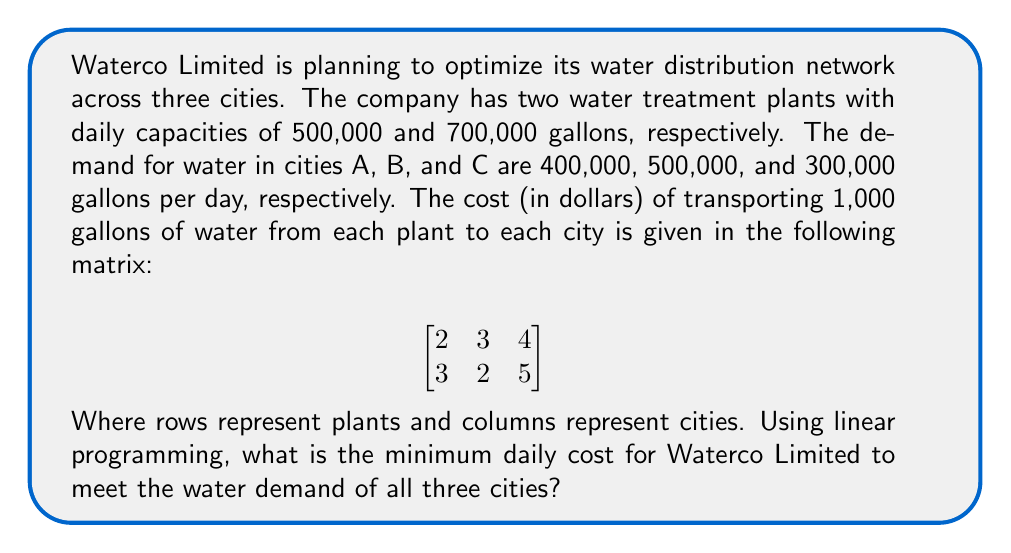Help me with this question. To solve this problem, we need to set up a linear programming model and solve it. Let's follow these steps:

1. Define variables:
   Let $x_{ij}$ be the amount of water (in thousands of gallons) sent from plant i to city j.

2. Objective function:
   Minimize total cost: 
   $$Z = 2x_{11} + 3x_{12} + 4x_{13} + 3x_{21} + 2x_{22} + 5x_{23}$$

3. Constraints:
   a) Supply constraints:
      Plant 1: $x_{11} + x_{12} + x_{13} \leq 500$
      Plant 2: $x_{21} + x_{22} + x_{23} \leq 700$

   b) Demand constraints:
      City A: $x_{11} + x_{21} = 400$
      City B: $x_{12} + x_{22} = 500$
      City C: $x_{13} + x_{23} = 300$

   c) Non-negativity constraints:
      $x_{ij} \geq 0$ for all i and j

4. Solve using a linear programming solver (e.g., simplex method):
   The optimal solution is:
   $x_{11} = 400, x_{12} = 100, x_{13} = 0$
   $x_{21} = 0, x_{22} = 400, x_{23} = 300$

5. Calculate the minimum cost:
   $$Z = 2(400) + 3(100) + 4(0) + 3(0) + 2(400) + 5(300)$$
   $$Z = 800 + 300 + 800 + 1500 = 3400$$

Therefore, the minimum daily cost for Waterco Limited to meet the water demand of all three cities is $3,400.
Answer: $3,400 